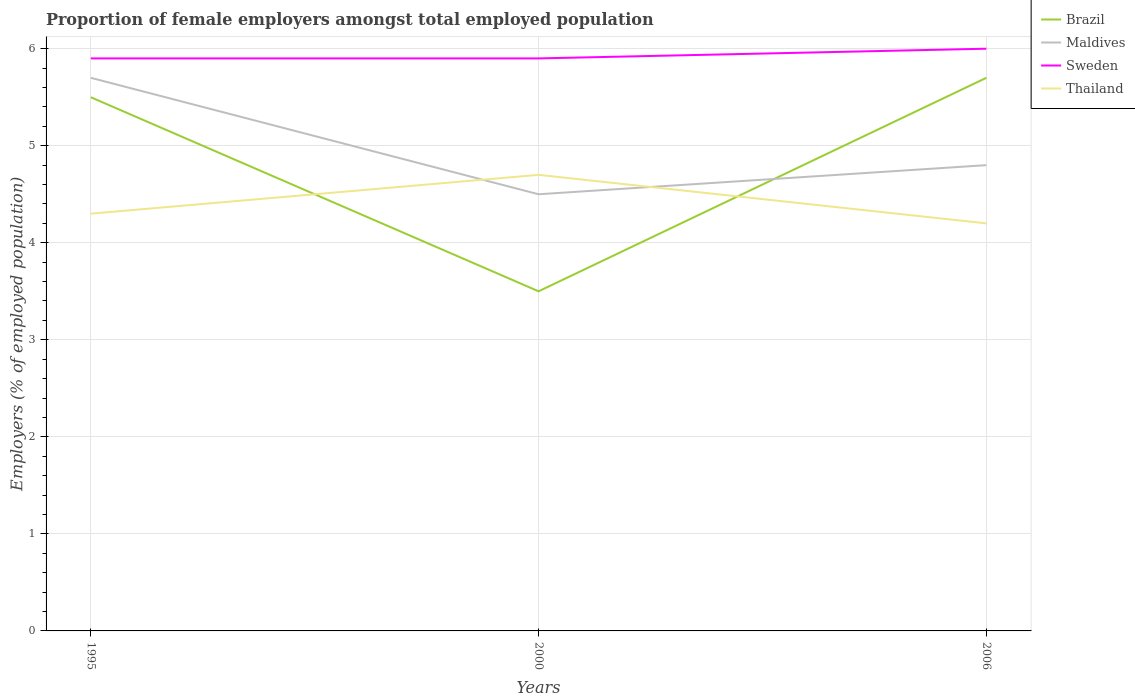How many different coloured lines are there?
Provide a short and direct response. 4. Is the number of lines equal to the number of legend labels?
Provide a short and direct response. Yes. Across all years, what is the maximum proportion of female employers in Brazil?
Give a very brief answer. 3.5. In which year was the proportion of female employers in Brazil maximum?
Provide a succinct answer. 2000. What is the total proportion of female employers in Brazil in the graph?
Offer a terse response. -2.2. What is the difference between the highest and the second highest proportion of female employers in Sweden?
Your answer should be very brief. 0.1. What is the difference between the highest and the lowest proportion of female employers in Brazil?
Your response must be concise. 2. How many years are there in the graph?
Your response must be concise. 3. Does the graph contain any zero values?
Your answer should be very brief. No. Does the graph contain grids?
Your answer should be very brief. Yes. How are the legend labels stacked?
Offer a terse response. Vertical. What is the title of the graph?
Provide a succinct answer. Proportion of female employers amongst total employed population. Does "Andorra" appear as one of the legend labels in the graph?
Your answer should be very brief. No. What is the label or title of the X-axis?
Your answer should be compact. Years. What is the label or title of the Y-axis?
Offer a terse response. Employers (% of employed population). What is the Employers (% of employed population) in Brazil in 1995?
Your response must be concise. 5.5. What is the Employers (% of employed population) of Maldives in 1995?
Provide a short and direct response. 5.7. What is the Employers (% of employed population) of Sweden in 1995?
Provide a succinct answer. 5.9. What is the Employers (% of employed population) of Thailand in 1995?
Give a very brief answer. 4.3. What is the Employers (% of employed population) of Brazil in 2000?
Provide a short and direct response. 3.5. What is the Employers (% of employed population) of Maldives in 2000?
Your answer should be very brief. 4.5. What is the Employers (% of employed population) in Sweden in 2000?
Make the answer very short. 5.9. What is the Employers (% of employed population) in Thailand in 2000?
Offer a terse response. 4.7. What is the Employers (% of employed population) in Brazil in 2006?
Provide a short and direct response. 5.7. What is the Employers (% of employed population) of Maldives in 2006?
Provide a succinct answer. 4.8. What is the Employers (% of employed population) in Sweden in 2006?
Your answer should be very brief. 6. What is the Employers (% of employed population) in Thailand in 2006?
Provide a short and direct response. 4.2. Across all years, what is the maximum Employers (% of employed population) in Brazil?
Provide a succinct answer. 5.7. Across all years, what is the maximum Employers (% of employed population) in Maldives?
Your answer should be very brief. 5.7. Across all years, what is the maximum Employers (% of employed population) of Sweden?
Your answer should be compact. 6. Across all years, what is the maximum Employers (% of employed population) of Thailand?
Offer a very short reply. 4.7. Across all years, what is the minimum Employers (% of employed population) in Brazil?
Keep it short and to the point. 3.5. Across all years, what is the minimum Employers (% of employed population) of Maldives?
Your answer should be very brief. 4.5. Across all years, what is the minimum Employers (% of employed population) in Sweden?
Provide a short and direct response. 5.9. Across all years, what is the minimum Employers (% of employed population) of Thailand?
Your answer should be very brief. 4.2. What is the total Employers (% of employed population) in Brazil in the graph?
Provide a succinct answer. 14.7. What is the total Employers (% of employed population) of Thailand in the graph?
Offer a very short reply. 13.2. What is the difference between the Employers (% of employed population) in Sweden in 1995 and that in 2006?
Ensure brevity in your answer.  -0.1. What is the difference between the Employers (% of employed population) in Thailand in 1995 and that in 2006?
Make the answer very short. 0.1. What is the difference between the Employers (% of employed population) in Maldives in 2000 and that in 2006?
Keep it short and to the point. -0.3. What is the difference between the Employers (% of employed population) in Thailand in 2000 and that in 2006?
Your answer should be very brief. 0.5. What is the difference between the Employers (% of employed population) of Maldives in 1995 and the Employers (% of employed population) of Thailand in 2000?
Give a very brief answer. 1. What is the difference between the Employers (% of employed population) of Sweden in 1995 and the Employers (% of employed population) of Thailand in 2000?
Ensure brevity in your answer.  1.2. What is the difference between the Employers (% of employed population) in Brazil in 1995 and the Employers (% of employed population) in Maldives in 2006?
Ensure brevity in your answer.  0.7. What is the difference between the Employers (% of employed population) of Maldives in 1995 and the Employers (% of employed population) of Sweden in 2006?
Provide a short and direct response. -0.3. What is the difference between the Employers (% of employed population) in Sweden in 1995 and the Employers (% of employed population) in Thailand in 2006?
Offer a very short reply. 1.7. What is the difference between the Employers (% of employed population) in Brazil in 2000 and the Employers (% of employed population) in Maldives in 2006?
Offer a very short reply. -1.3. What is the difference between the Employers (% of employed population) in Brazil in 2000 and the Employers (% of employed population) in Sweden in 2006?
Provide a short and direct response. -2.5. What is the difference between the Employers (% of employed population) in Brazil in 2000 and the Employers (% of employed population) in Thailand in 2006?
Make the answer very short. -0.7. What is the difference between the Employers (% of employed population) in Maldives in 2000 and the Employers (% of employed population) in Thailand in 2006?
Give a very brief answer. 0.3. What is the difference between the Employers (% of employed population) in Sweden in 2000 and the Employers (% of employed population) in Thailand in 2006?
Your response must be concise. 1.7. What is the average Employers (% of employed population) in Brazil per year?
Provide a short and direct response. 4.9. What is the average Employers (% of employed population) of Maldives per year?
Provide a short and direct response. 5. What is the average Employers (% of employed population) of Sweden per year?
Offer a terse response. 5.93. What is the average Employers (% of employed population) in Thailand per year?
Ensure brevity in your answer.  4.4. In the year 1995, what is the difference between the Employers (% of employed population) in Brazil and Employers (% of employed population) in Maldives?
Keep it short and to the point. -0.2. In the year 1995, what is the difference between the Employers (% of employed population) in Brazil and Employers (% of employed population) in Sweden?
Ensure brevity in your answer.  -0.4. In the year 1995, what is the difference between the Employers (% of employed population) of Maldives and Employers (% of employed population) of Sweden?
Ensure brevity in your answer.  -0.2. In the year 1995, what is the difference between the Employers (% of employed population) in Sweden and Employers (% of employed population) in Thailand?
Your answer should be compact. 1.6. In the year 2000, what is the difference between the Employers (% of employed population) of Brazil and Employers (% of employed population) of Maldives?
Make the answer very short. -1. In the year 2000, what is the difference between the Employers (% of employed population) of Brazil and Employers (% of employed population) of Sweden?
Keep it short and to the point. -2.4. In the year 2000, what is the difference between the Employers (% of employed population) in Brazil and Employers (% of employed population) in Thailand?
Offer a very short reply. -1.2. In the year 2006, what is the difference between the Employers (% of employed population) of Brazil and Employers (% of employed population) of Thailand?
Offer a terse response. 1.5. In the year 2006, what is the difference between the Employers (% of employed population) in Maldives and Employers (% of employed population) in Thailand?
Ensure brevity in your answer.  0.6. What is the ratio of the Employers (% of employed population) in Brazil in 1995 to that in 2000?
Make the answer very short. 1.57. What is the ratio of the Employers (% of employed population) in Maldives in 1995 to that in 2000?
Provide a short and direct response. 1.27. What is the ratio of the Employers (% of employed population) in Thailand in 1995 to that in 2000?
Provide a short and direct response. 0.91. What is the ratio of the Employers (% of employed population) of Brazil in 1995 to that in 2006?
Provide a short and direct response. 0.96. What is the ratio of the Employers (% of employed population) of Maldives in 1995 to that in 2006?
Provide a short and direct response. 1.19. What is the ratio of the Employers (% of employed population) in Sweden in 1995 to that in 2006?
Provide a succinct answer. 0.98. What is the ratio of the Employers (% of employed population) of Thailand in 1995 to that in 2006?
Offer a very short reply. 1.02. What is the ratio of the Employers (% of employed population) in Brazil in 2000 to that in 2006?
Your answer should be very brief. 0.61. What is the ratio of the Employers (% of employed population) of Sweden in 2000 to that in 2006?
Your response must be concise. 0.98. What is the ratio of the Employers (% of employed population) in Thailand in 2000 to that in 2006?
Ensure brevity in your answer.  1.12. What is the difference between the highest and the second highest Employers (% of employed population) in Brazil?
Your response must be concise. 0.2. What is the difference between the highest and the second highest Employers (% of employed population) in Maldives?
Give a very brief answer. 0.9. What is the difference between the highest and the second highest Employers (% of employed population) of Sweden?
Make the answer very short. 0.1. What is the difference between the highest and the second highest Employers (% of employed population) of Thailand?
Your answer should be compact. 0.4. What is the difference between the highest and the lowest Employers (% of employed population) of Brazil?
Your answer should be compact. 2.2. What is the difference between the highest and the lowest Employers (% of employed population) in Thailand?
Provide a succinct answer. 0.5. 